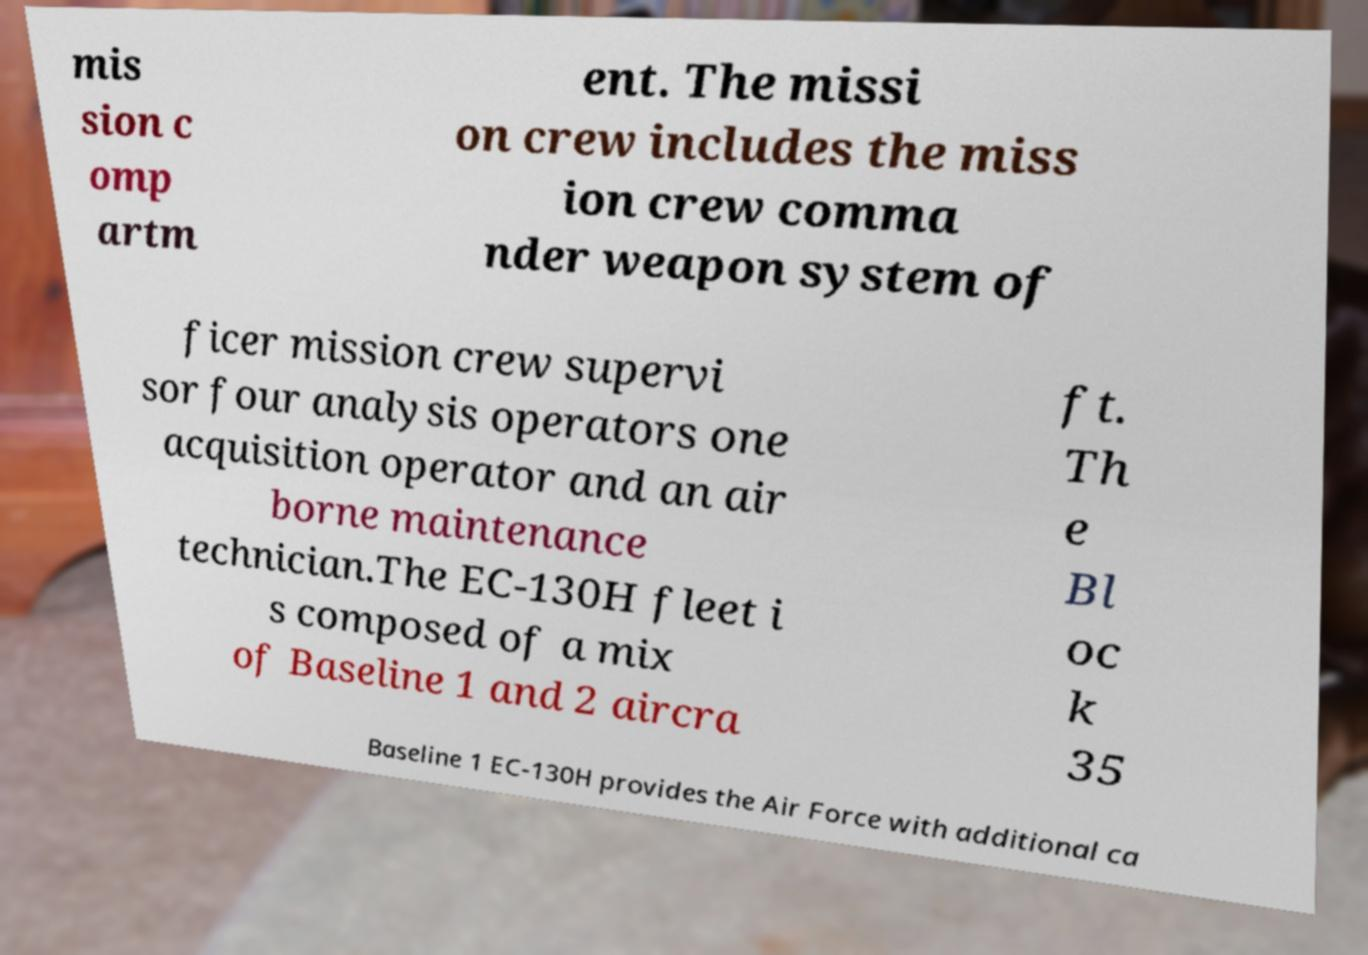Please read and relay the text visible in this image. What does it say? mis sion c omp artm ent. The missi on crew includes the miss ion crew comma nder weapon system of ficer mission crew supervi sor four analysis operators one acquisition operator and an air borne maintenance technician.The EC-130H fleet i s composed of a mix of Baseline 1 and 2 aircra ft. Th e Bl oc k 35 Baseline 1 EC-130H provides the Air Force with additional ca 